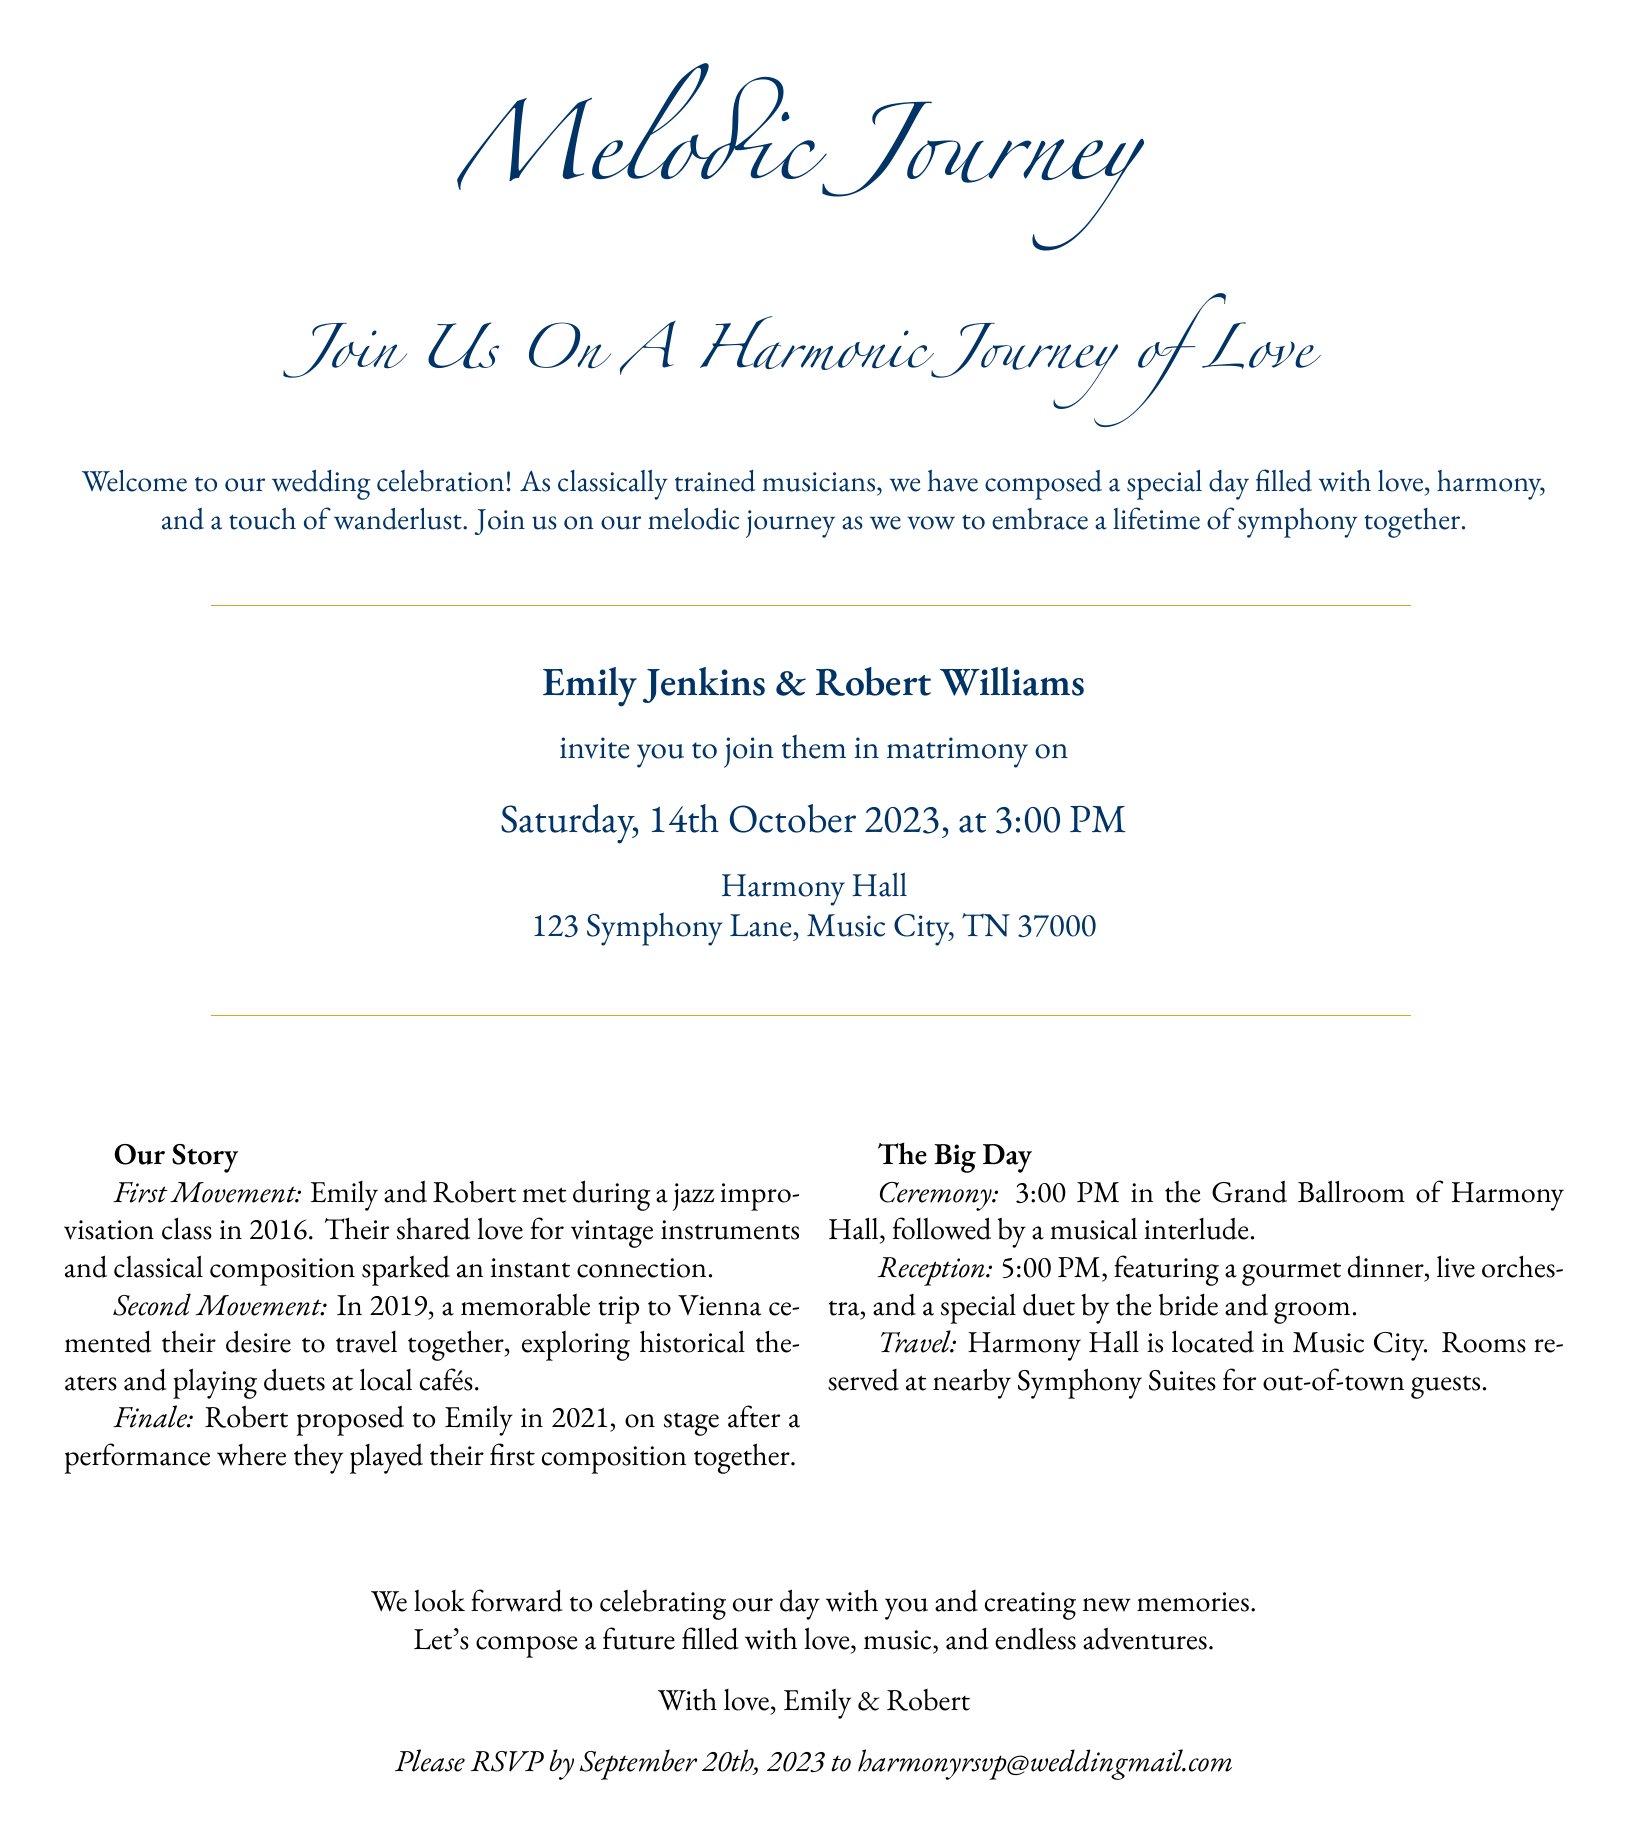What is the name of the bride? The bride's name is mentioned in the invitation as Emily Jenkins.
Answer: Emily Jenkins What is the date of the wedding? The wedding date is stated clearly in the invitation, which is Saturday, October 14th, 2023.
Answer: October 14th, 2023 Where will the ceremony take place? The location of the ceremony is identified in the invitation as Harmony Hall.
Answer: Harmony Hall What time is the reception scheduled to start? The invitation specifies that the reception begins at 5:00 PM.
Answer: 5:00 PM In which city is Harmony Hall located? The city where Harmony Hall is situated is mentioned as Music City.
Answer: Music City What does the first movement of their story represent? The first movement describes how Emily and Robert met during a jazz improvisation class in 2016.
Answer: Meeting in 2016 What is the theme of the wedding invitation design? The design theme combines travel with musical elements, reflected in the title "Melodic Journey."
Answer: Melodic Journey When is the RSVP deadline? The RSVP deadline is stated in the invitation as September 20th, 2023.
Answer: September 20th, 2023 What type of dinner will be featured at the reception? The invitation mentions that the reception will feature a gourmet dinner.
Answer: Gourmet dinner 